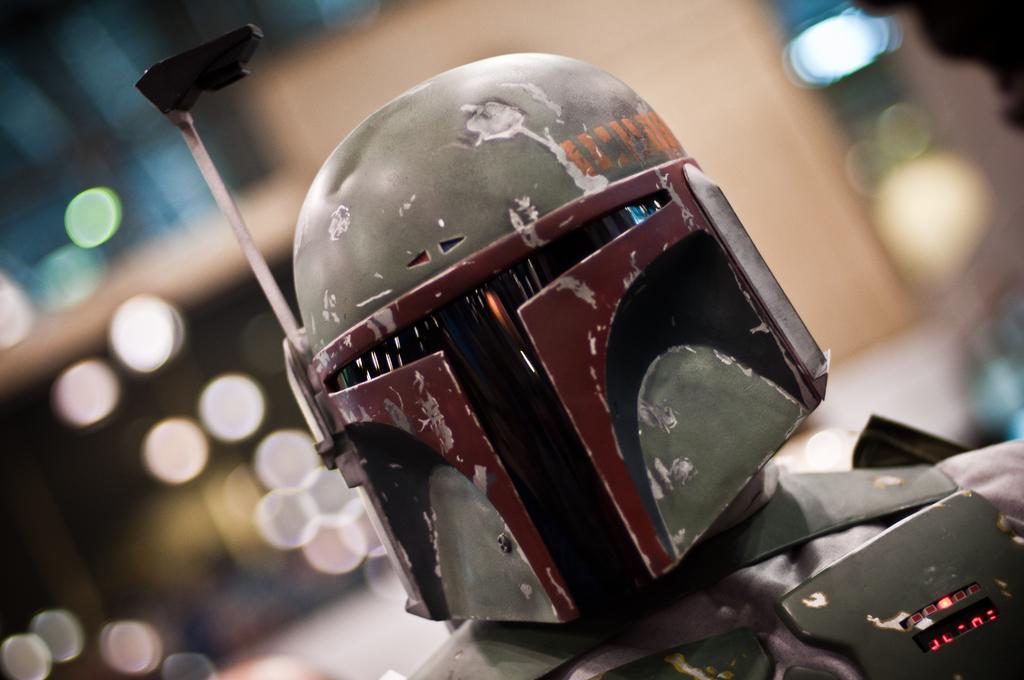In one or two sentences, can you explain what this image depicts? In this image, we can see a person wearing a costume and the background is blurred. 